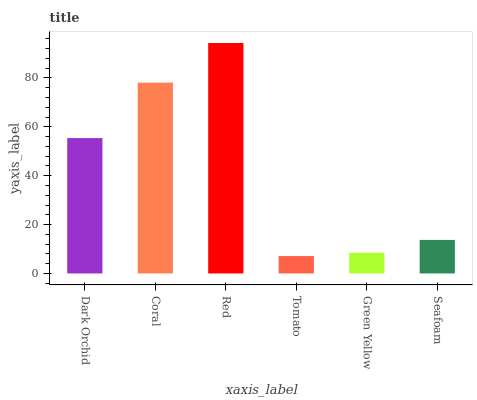Is Tomato the minimum?
Answer yes or no. Yes. Is Red the maximum?
Answer yes or no. Yes. Is Coral the minimum?
Answer yes or no. No. Is Coral the maximum?
Answer yes or no. No. Is Coral greater than Dark Orchid?
Answer yes or no. Yes. Is Dark Orchid less than Coral?
Answer yes or no. Yes. Is Dark Orchid greater than Coral?
Answer yes or no. No. Is Coral less than Dark Orchid?
Answer yes or no. No. Is Dark Orchid the high median?
Answer yes or no. Yes. Is Seafoam the low median?
Answer yes or no. Yes. Is Seafoam the high median?
Answer yes or no. No. Is Tomato the low median?
Answer yes or no. No. 